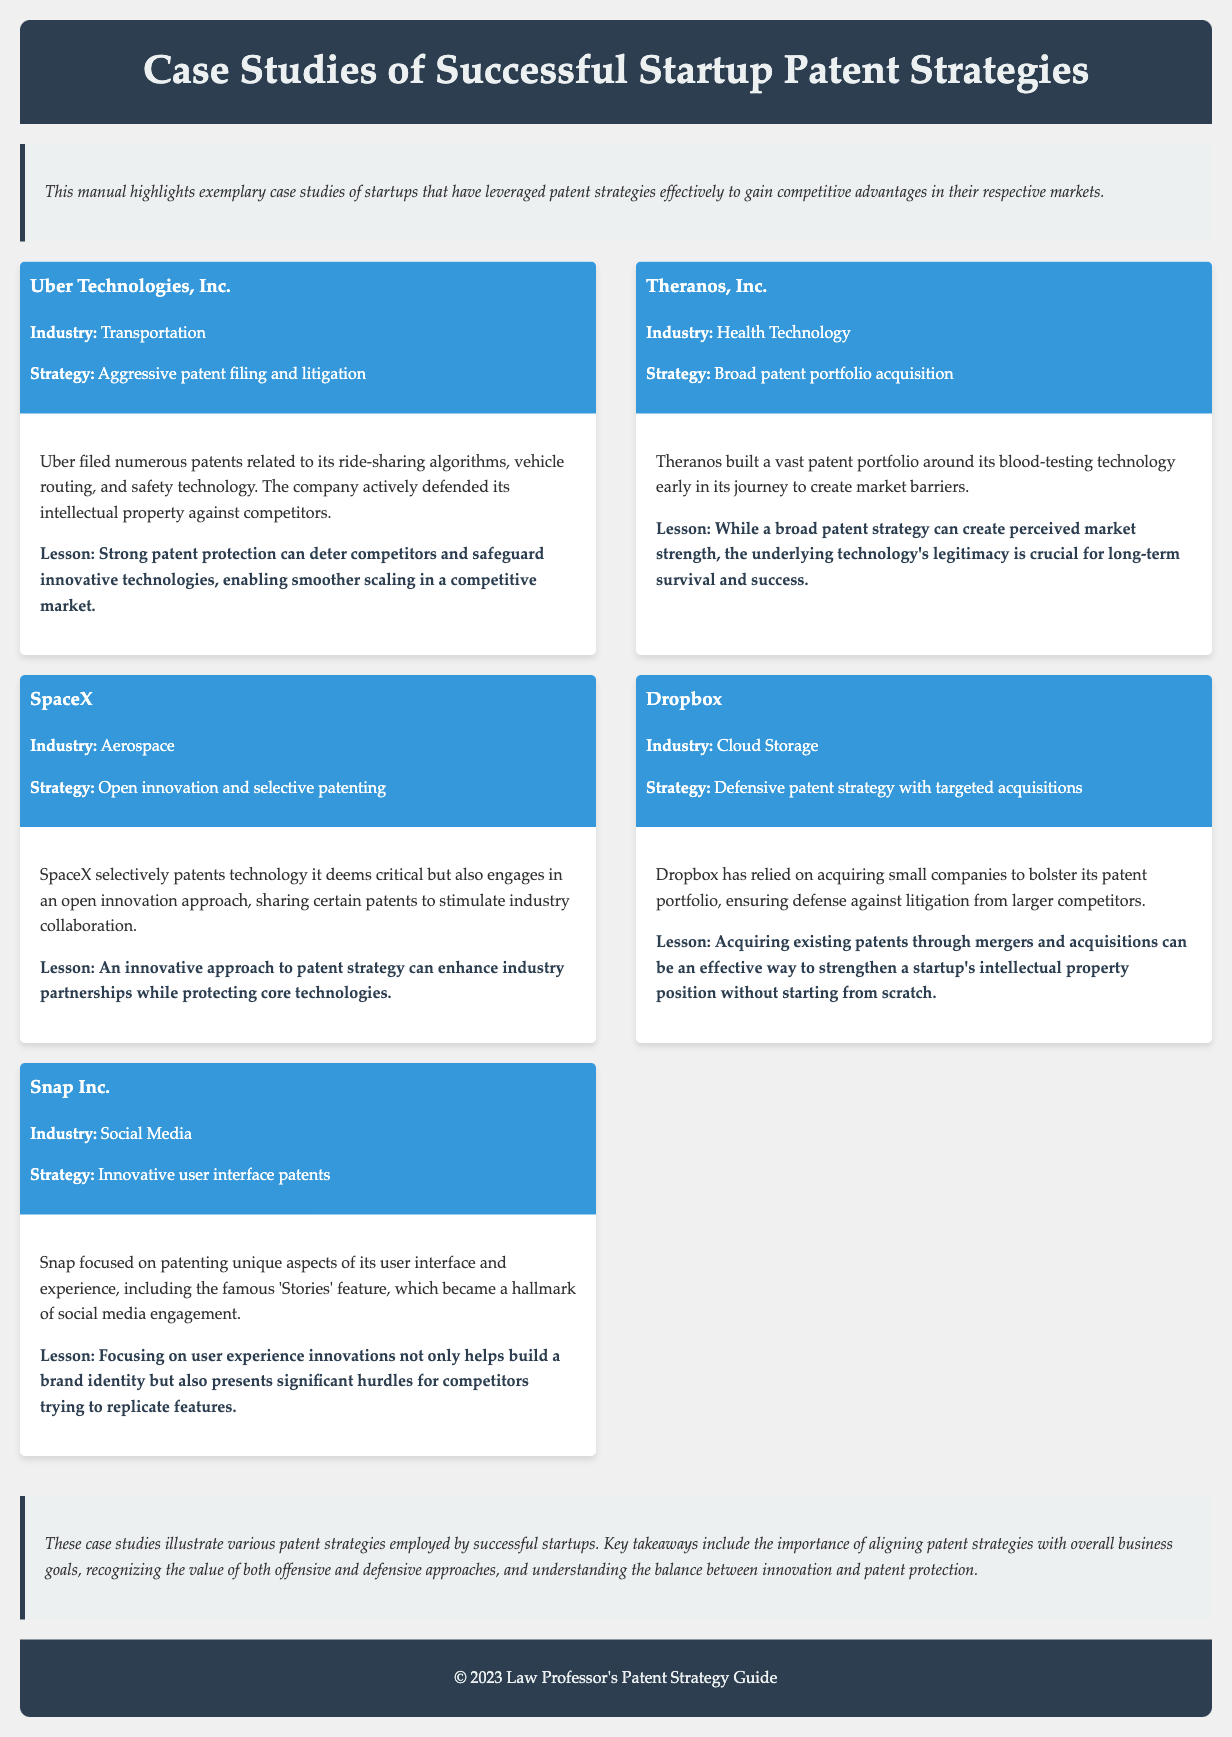What is the first case study mentioned? The first case study listed in the document is about Uber Technologies, Inc.
Answer: Uber Technologies, Inc Which industry does SpaceX operate in? The document specifies that SpaceX operates in the Aerospace industry.
Answer: Aerospace What patent strategy did Dropbox employ? Dropbox used a defensive patent strategy with targeted acquisitions as highlighted in the case study.
Answer: Defensive patent strategy with targeted acquisitions What lesson does the Theranos case provide? The lesson from the Theranos case emphasizes the importance of the underlying technology's legitimacy for long-term success.
Answer: The underlying technology's legitimacy is crucial for long-term survival and success How many case studies are mentioned in the document? The document presents a total of five case studies.
Answer: Five 